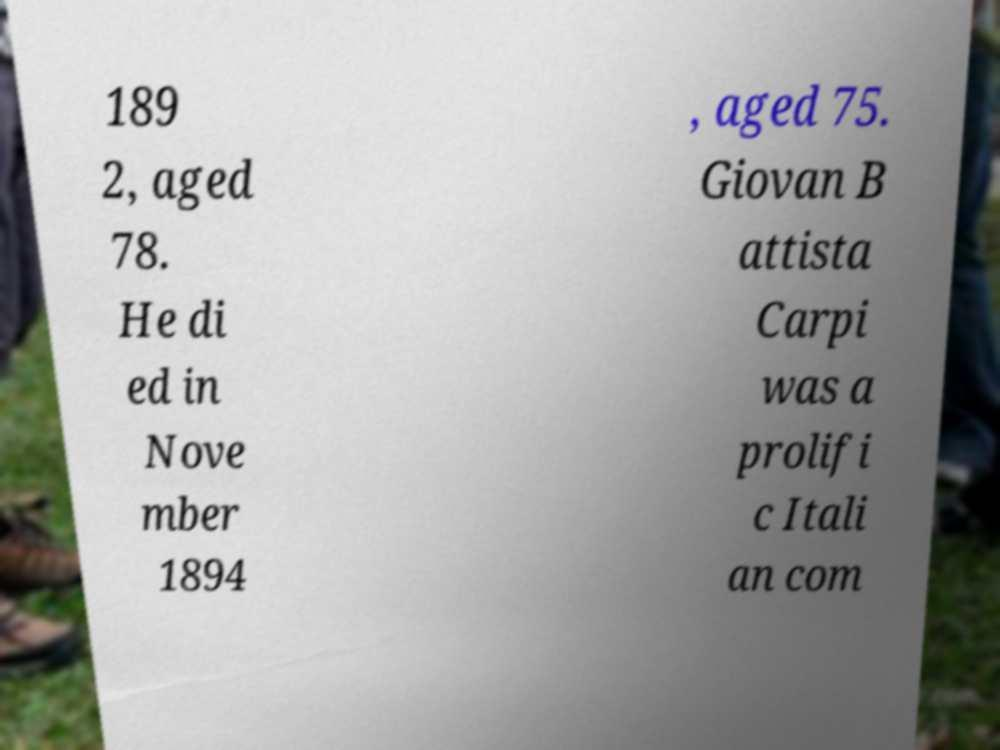Can you read and provide the text displayed in the image?This photo seems to have some interesting text. Can you extract and type it out for me? 189 2, aged 78. He di ed in Nove mber 1894 , aged 75. Giovan B attista Carpi was a prolifi c Itali an com 